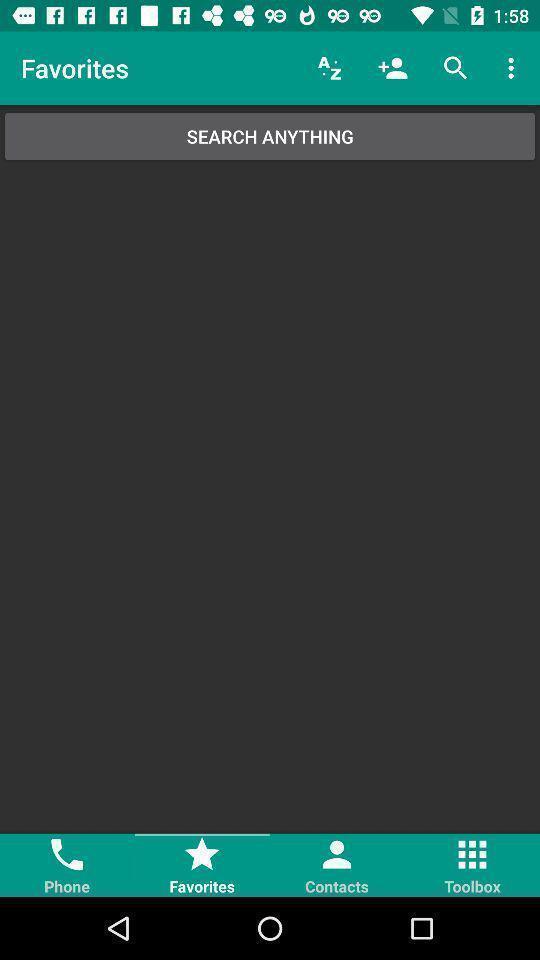Explain what's happening in this screen capture. Search anything in the favorites. 